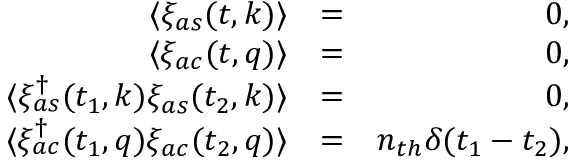Convert formula to latex. <formula><loc_0><loc_0><loc_500><loc_500>\begin{array} { r l r } { \langle \xi _ { a s } ( t , k ) \rangle } & { = } & { 0 , } \\ { \langle \xi _ { a c } ( t , q ) \rangle } & { = } & { 0 , } \\ { \langle \xi _ { a s } ^ { \dagger } ( t _ { 1 } , k ) \xi _ { a s } ( t _ { 2 } , k ) \rangle } & { = } & { 0 , } \\ { \langle \xi _ { a c } ^ { \dagger } ( t _ { 1 } , q ) \xi _ { a c } ( t _ { 2 } , q ) \rangle } & { = } & { n _ { t h } \delta ( t _ { 1 } - t _ { 2 } ) , } \end{array}</formula> 